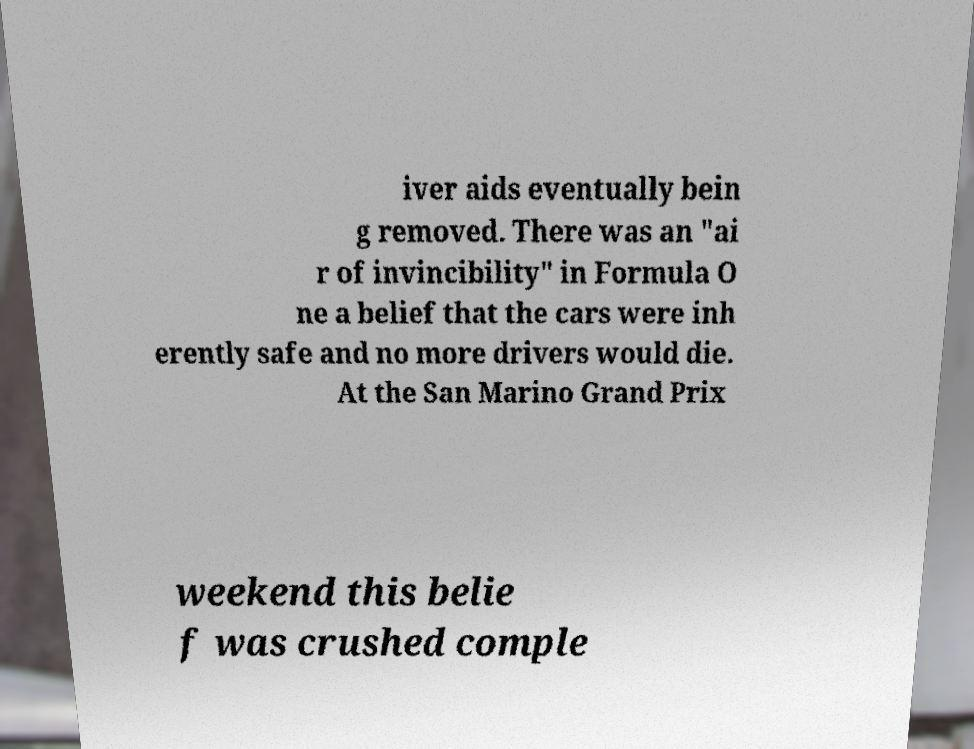For documentation purposes, I need the text within this image transcribed. Could you provide that? iver aids eventually bein g removed. There was an "ai r of invincibility" in Formula O ne a belief that the cars were inh erently safe and no more drivers would die. At the San Marino Grand Prix weekend this belie f was crushed comple 